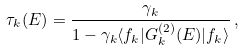Convert formula to latex. <formula><loc_0><loc_0><loc_500><loc_500>\tau _ { k } ( E ) = \frac { \gamma _ { k } } { 1 - \gamma _ { k } \langle f _ { k } | G _ { k } ^ { ( 2 ) } ( E ) | f _ { k } \rangle } \, ,</formula> 